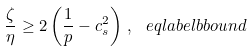<formula> <loc_0><loc_0><loc_500><loc_500>\frac { \zeta } { \eta } \geq 2 \left ( \frac { 1 } { p } - c _ { s } ^ { 2 } \right ) \, , \ e q l a b e l { b b o u n d }</formula> 